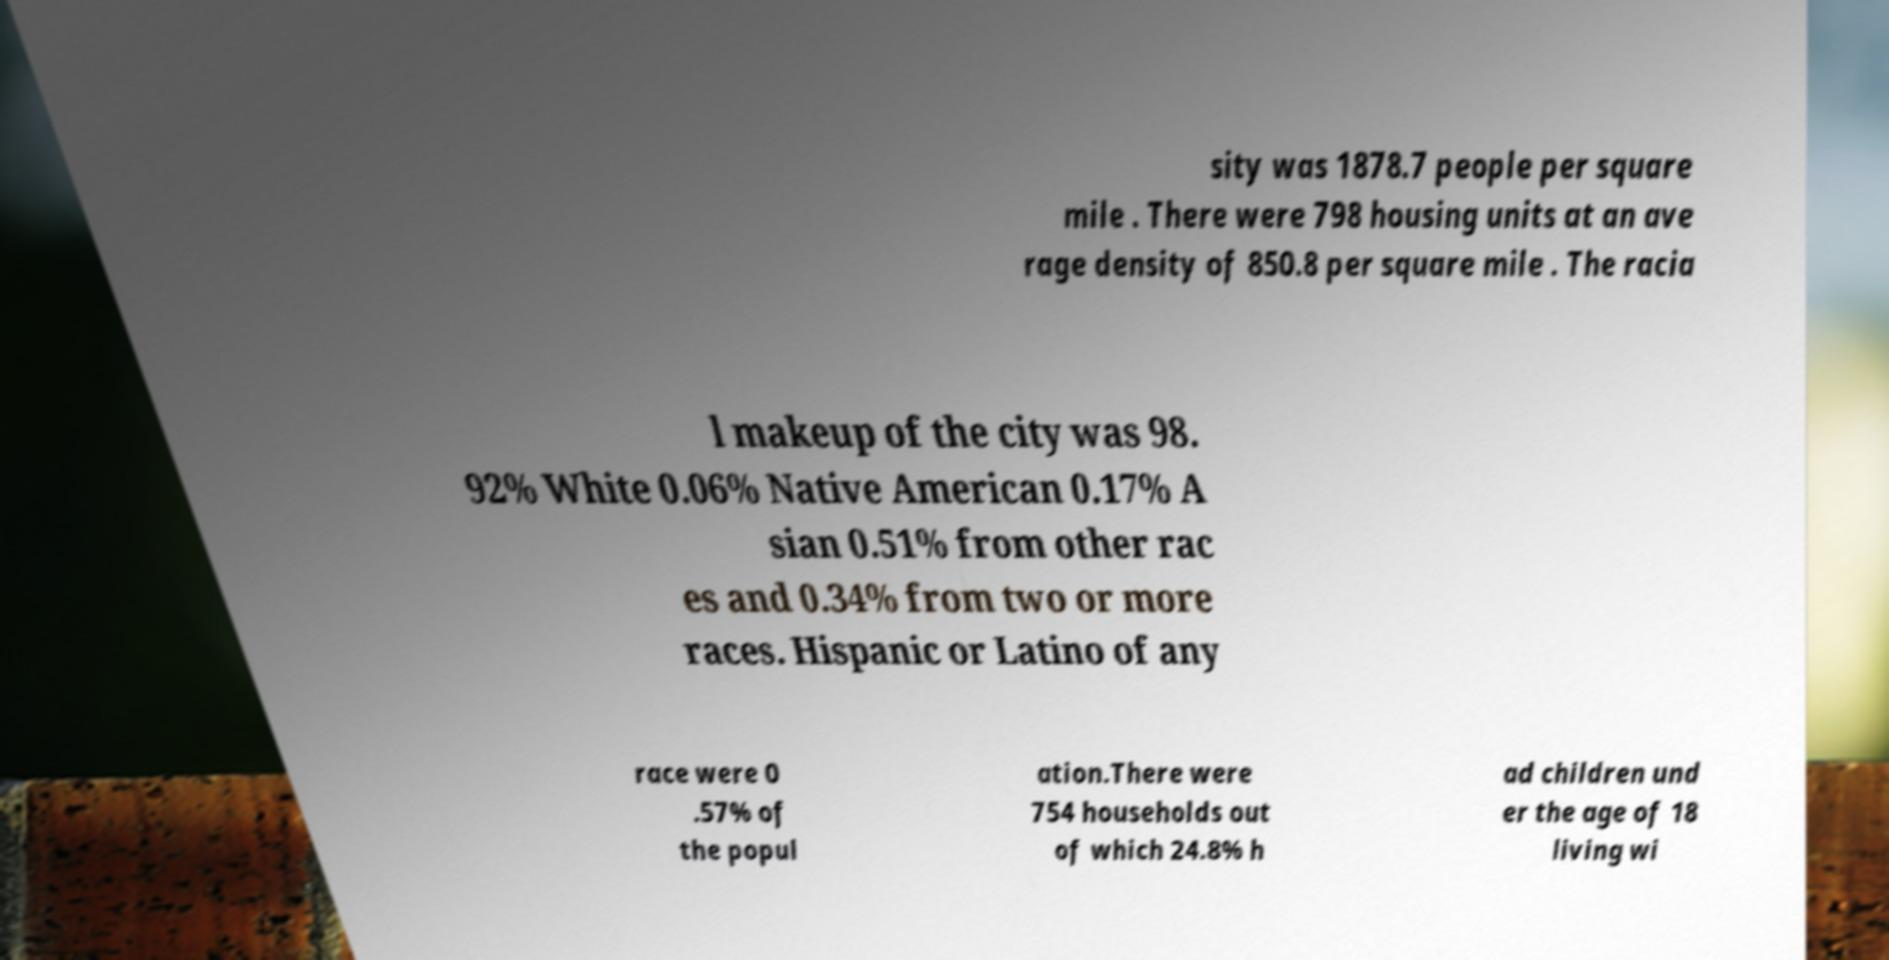Could you extract and type out the text from this image? sity was 1878.7 people per square mile . There were 798 housing units at an ave rage density of 850.8 per square mile . The racia l makeup of the city was 98. 92% White 0.06% Native American 0.17% A sian 0.51% from other rac es and 0.34% from two or more races. Hispanic or Latino of any race were 0 .57% of the popul ation.There were 754 households out of which 24.8% h ad children und er the age of 18 living wi 